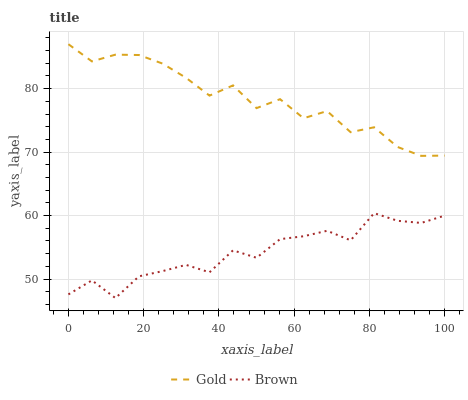Does Brown have the minimum area under the curve?
Answer yes or no. Yes. Does Gold have the maximum area under the curve?
Answer yes or no. Yes. Does Gold have the minimum area under the curve?
Answer yes or no. No. Is Gold the smoothest?
Answer yes or no. Yes. Is Brown the roughest?
Answer yes or no. Yes. Is Gold the roughest?
Answer yes or no. No. Does Brown have the lowest value?
Answer yes or no. Yes. Does Gold have the lowest value?
Answer yes or no. No. Does Gold have the highest value?
Answer yes or no. Yes. Is Brown less than Gold?
Answer yes or no. Yes. Is Gold greater than Brown?
Answer yes or no. Yes. Does Brown intersect Gold?
Answer yes or no. No. 